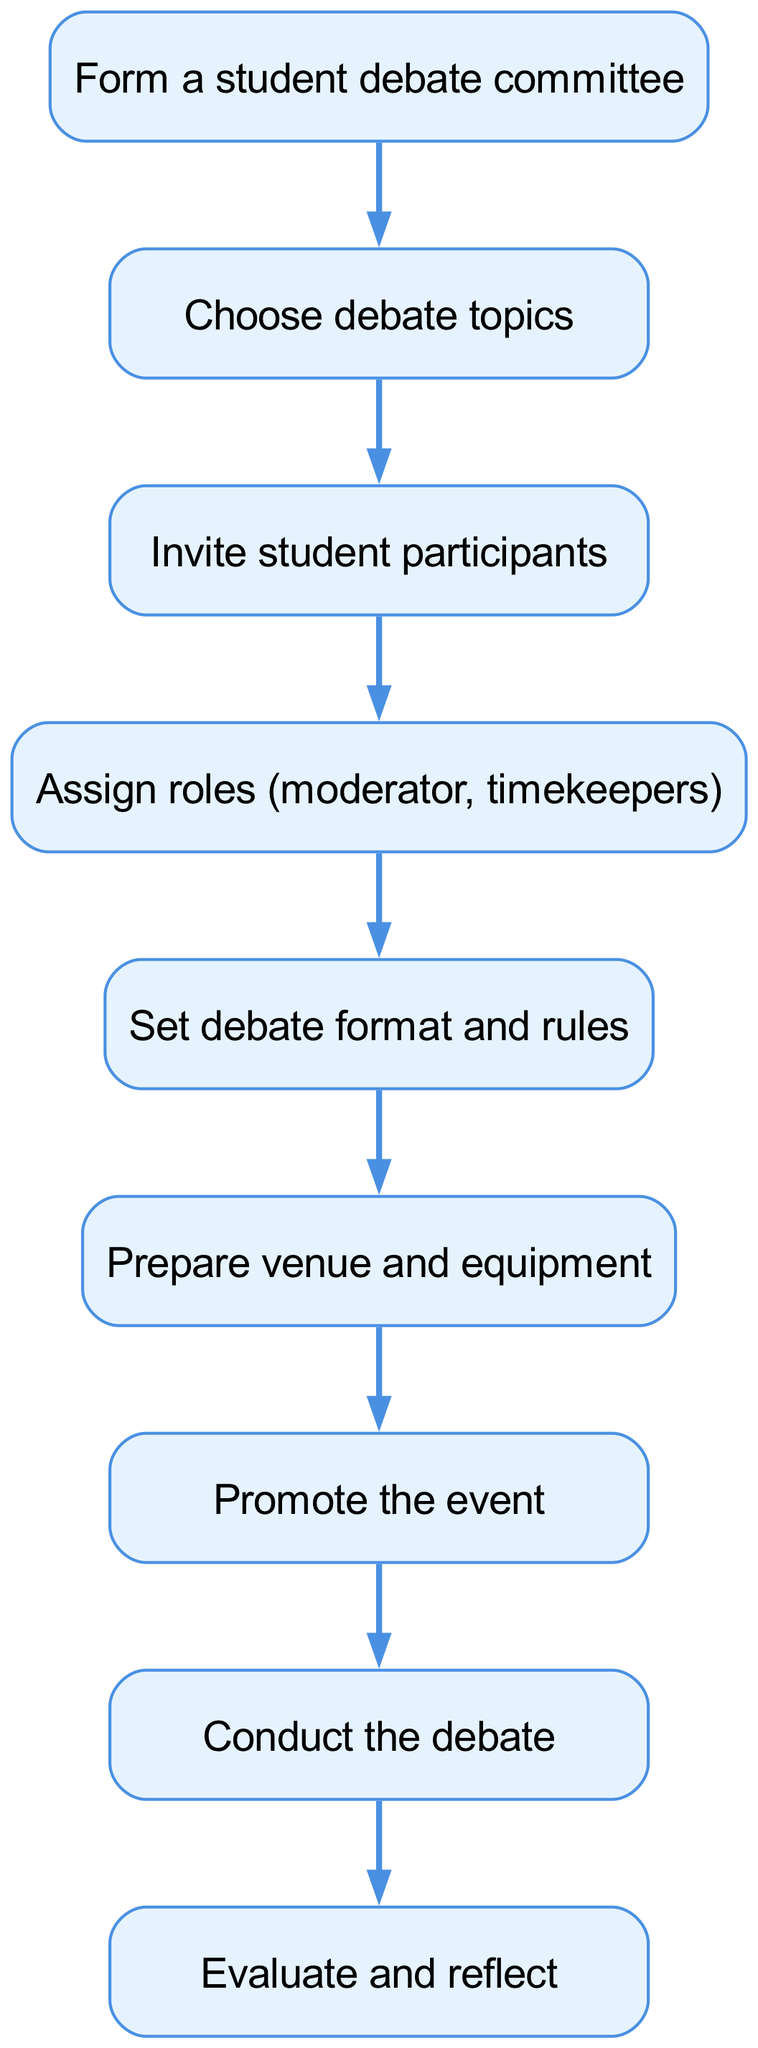What is the first step in organizing a student-led political debate? The first step is represented as the initial node in the diagram, which indicates "Form a student debate committee."
Answer: Form a student debate committee How many steps are there in total for organizing the debate? By counting all the elements in the diagram, there are a total of nine steps listed, ranging from forming a committee to evaluating and reflecting on the debate.
Answer: Nine What do you do immediately after choosing debate topics? After choosing debate topics, the next step indicated is to "Invite student participants," which shows the direct flow from one action to the next.
Answer: Invite student participants What role is assigned in step four? The fourth step involves assigning roles, specifically mentioned are "moderator" and "timekeepers," which directly specifies the roles involved in the debate process.
Answer: Moderator, timekeepers What is the final action taken in the process? The last step, which concludes the diagram, is to "Evaluate and reflect," marking the end of the organizational process for the debate.
Answer: Evaluate and reflect Which step involves setting rules for the debate? The step that involves setting rules is the fifth one, labeled "Set debate format and rules," indicating a crucial part of the debate preparation process.
Answer: Set debate format and rules What is required before promoting the event? Prior to promoting the event, the diagram specifies that the venue and equipment must be prepared, indicating a necessary preparatory step before publicizing.
Answer: Prepare venue and equipment What comes directly after conducting the debate? Following the step of conducting the debate, the diagram shows that the next action to take is to "Evaluate and reflect," indicating a logical progression in the sequence.
Answer: Evaluate and reflect 